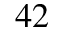<formula> <loc_0><loc_0><loc_500><loc_500>^ { 4 2 }</formula> 